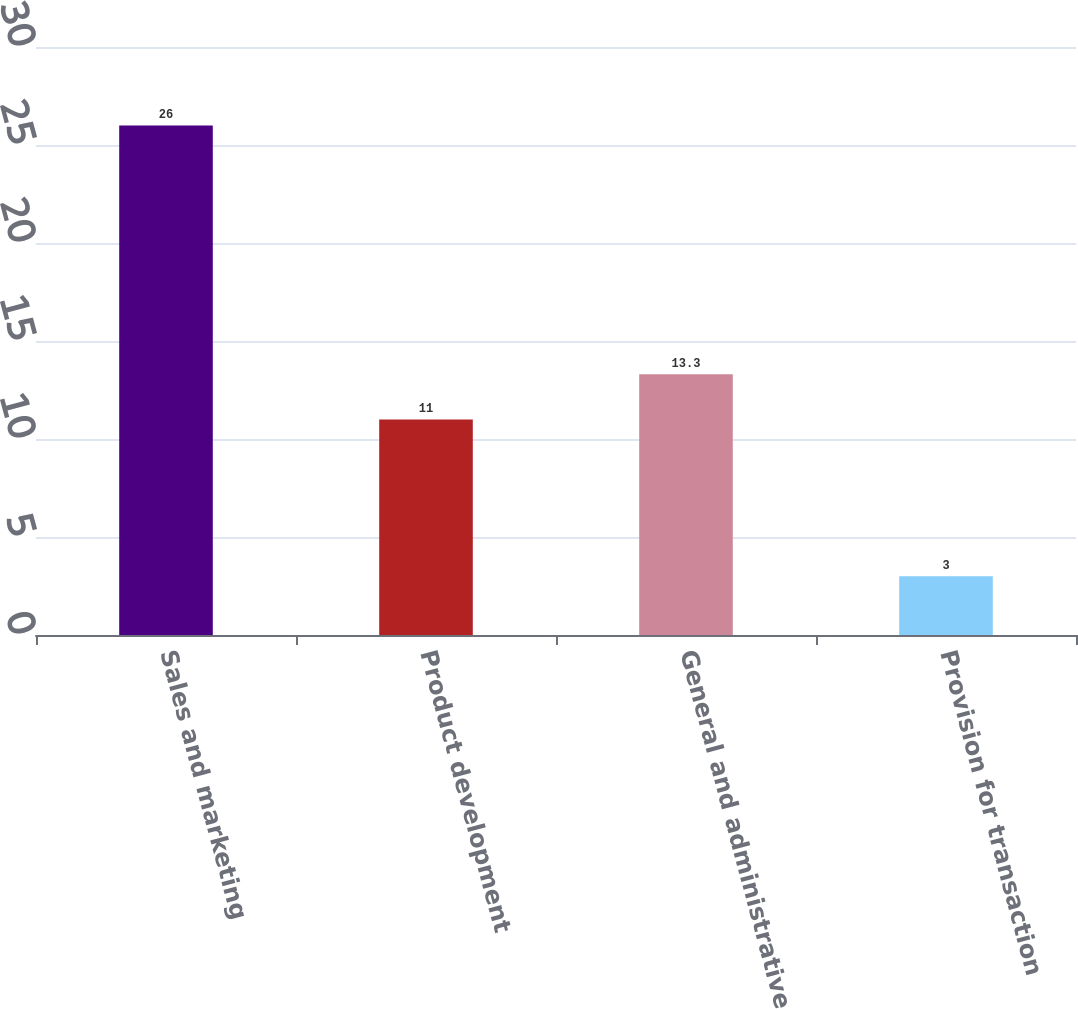Convert chart to OTSL. <chart><loc_0><loc_0><loc_500><loc_500><bar_chart><fcel>Sales and marketing<fcel>Product development<fcel>General and administrative<fcel>Provision for transaction<nl><fcel>26<fcel>11<fcel>13.3<fcel>3<nl></chart> 